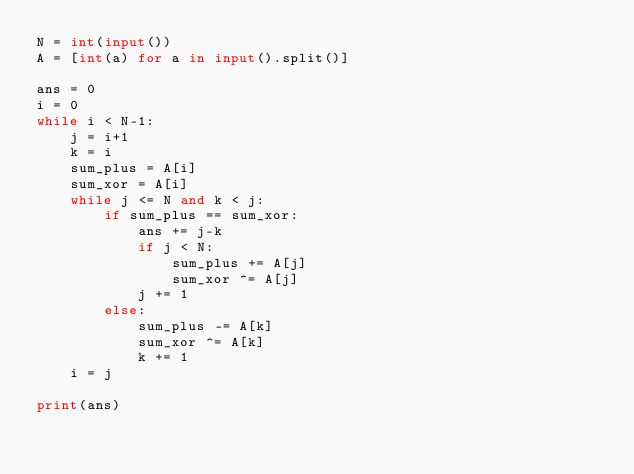Convert code to text. <code><loc_0><loc_0><loc_500><loc_500><_Python_>N = int(input())
A = [int(a) for a in input().split()]

ans = 0
i = 0
while i < N-1:
    j = i+1
    k = i
    sum_plus = A[i]
    sum_xor = A[i]
    while j <= N and k < j:
        if sum_plus == sum_xor:
            ans += j-k
            if j < N:
                sum_plus += A[j]
                sum_xor ^= A[j]
            j += 1
        else:
            sum_plus -= A[k]
            sum_xor ^= A[k]
            k += 1
    i = j
    
print(ans)</code> 